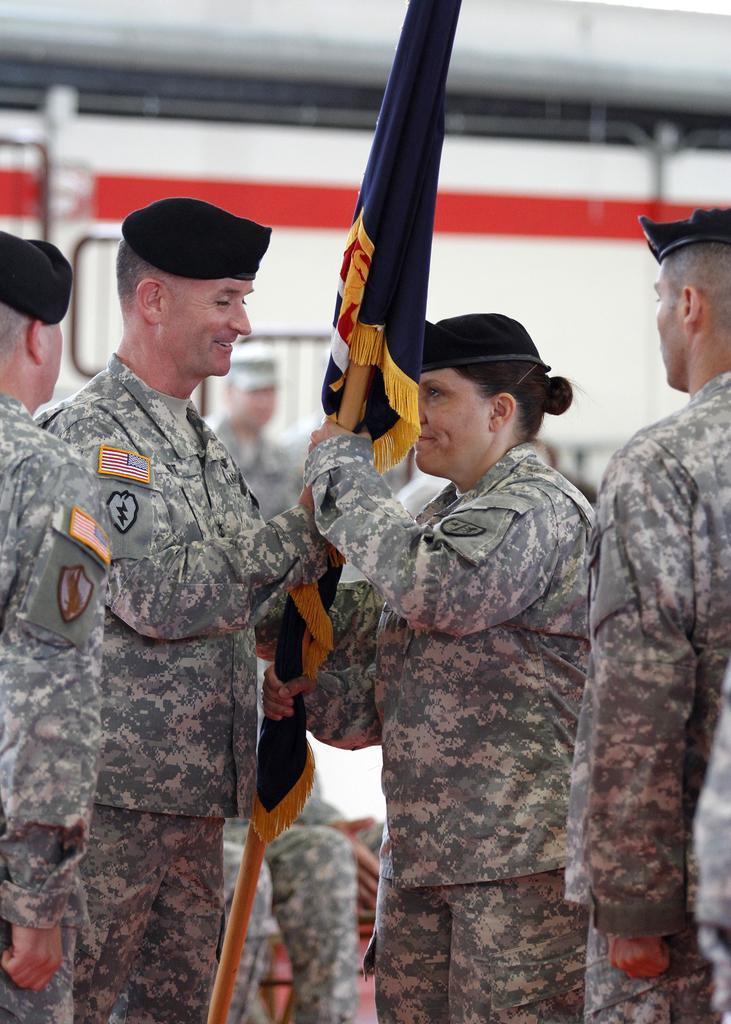Please provide a concise description of this image. In the middle of the picture, the man and the woman in uniform are holding a blue color flag in their hands. Behind them, we see a vehicle in white color. On either side of the picture, we see two men standing. 